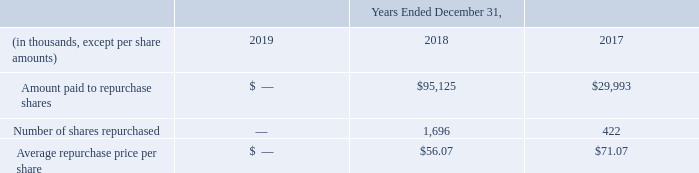Share Repurchase
In September 2015, our Board of Directors authorized a program to repurchase up to $150.0 million of our common stock over a thirty-month period. In November 2017, our Board of Directors approved an extension of the share repurchase program to December 2019 from its original maturity of March 2018. In May 2018, our Board of Directors approved a $50 million increase in its authorization to repurchase shares of our common stock under this same program.
On December 18, 2019, the Board of Directors authorized to remove the expiration date to the Company’s share repurchase program and increase the authorized amount by $25.1 million. As of December 31, 2019, the Company is authorized to repurchase shares of the Company’s common stock of up to a total of $50.0 million.
ADVANCED ENERGY INDUSTRIES, INC. NOTES TO CONSOLIDATED FINANCIAL STATEMENTS – (continued) (in thousands, except per share amounts)
In order to execute the repurchase of shares of our common stock, the Company periodically enters into stock repurchase agreements. During the years ended December 31, 2019, 2018 and 2017 the Company has repurchased the following shares of common stock:
What are the years included in the table? 2019, 2018, 2017. What was the number of shares repurchased in 2017?
Answer scale should be: thousand. 422. What was the average repurchase price per share in 2018? $56.07. What was the change in Amount paid to repurchase shares between 2017 and 2018?
Answer scale should be: thousand. $95,125-$29,993
Answer: 65132. What was the change in number of shares repurchased between 2017 and 2018?
Answer scale should be: thousand. 1,696-422
Answer: 1274. What was the percentage change in the average repurchase price per share between 2017 and 2018?
Answer scale should be: percent. ($56.07-$71.07)/$71.07
Answer: -21.11. 